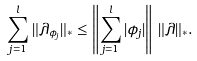<formula> <loc_0><loc_0><loc_500><loc_500>\sum _ { j = 1 } ^ { l } \| \lambda _ { \phi _ { j } } \| _ { * } \leq \left \| \sum _ { j = 1 } ^ { l } | \phi _ { j } | \right \| \, \| \lambda \| _ { * } .</formula> 